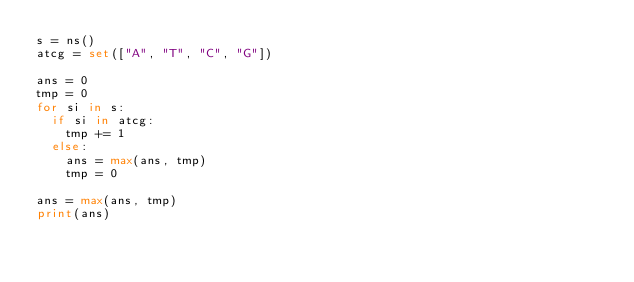Convert code to text. <code><loc_0><loc_0><loc_500><loc_500><_Python_>s = ns()
atcg = set(["A", "T", "C", "G"])

ans = 0
tmp = 0
for si in s:
  if si in atcg:
    tmp += 1
  else:
    ans = max(ans, tmp)
    tmp = 0
    
ans = max(ans, tmp)
print(ans)</code> 